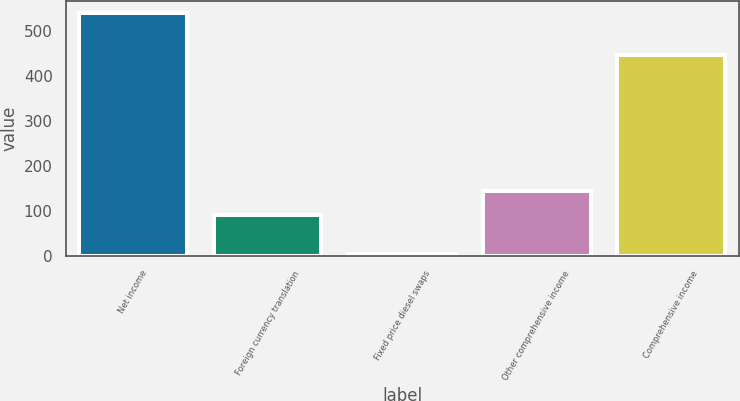Convert chart to OTSL. <chart><loc_0><loc_0><loc_500><loc_500><bar_chart><fcel>Net income<fcel>Foreign currency translation<fcel>Fixed price diesel swaps<fcel>Other comprehensive income<fcel>Comprehensive income<nl><fcel>540<fcel>90<fcel>3<fcel>143.7<fcel>447<nl></chart> 